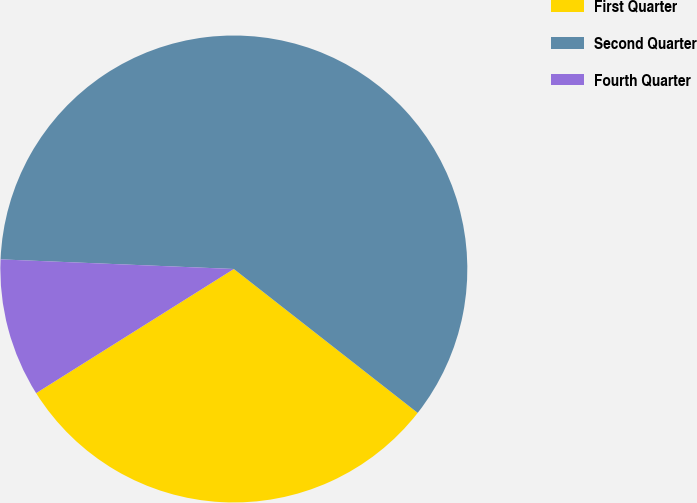Convert chart to OTSL. <chart><loc_0><loc_0><loc_500><loc_500><pie_chart><fcel>First Quarter<fcel>Second Quarter<fcel>Fourth Quarter<nl><fcel>30.51%<fcel>59.92%<fcel>9.58%<nl></chart> 